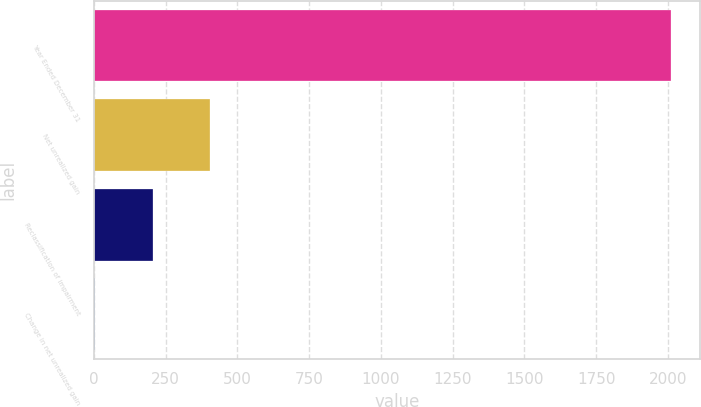<chart> <loc_0><loc_0><loc_500><loc_500><bar_chart><fcel>Year Ended December 31<fcel>Net unrealized gain<fcel>Reclassification of impairment<fcel>Change in net unrealized gain<nl><fcel>2011<fcel>405.4<fcel>204.7<fcel>4<nl></chart> 